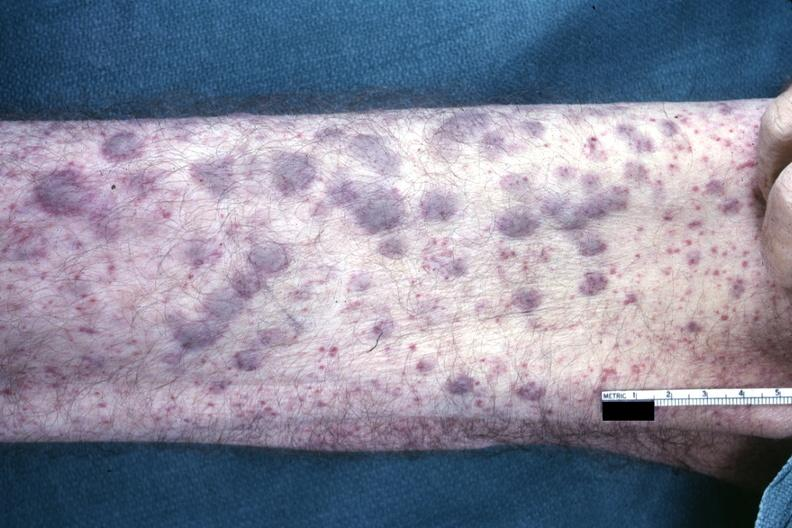does malignant thymoma show?
Answer the question using a single word or phrase. No 